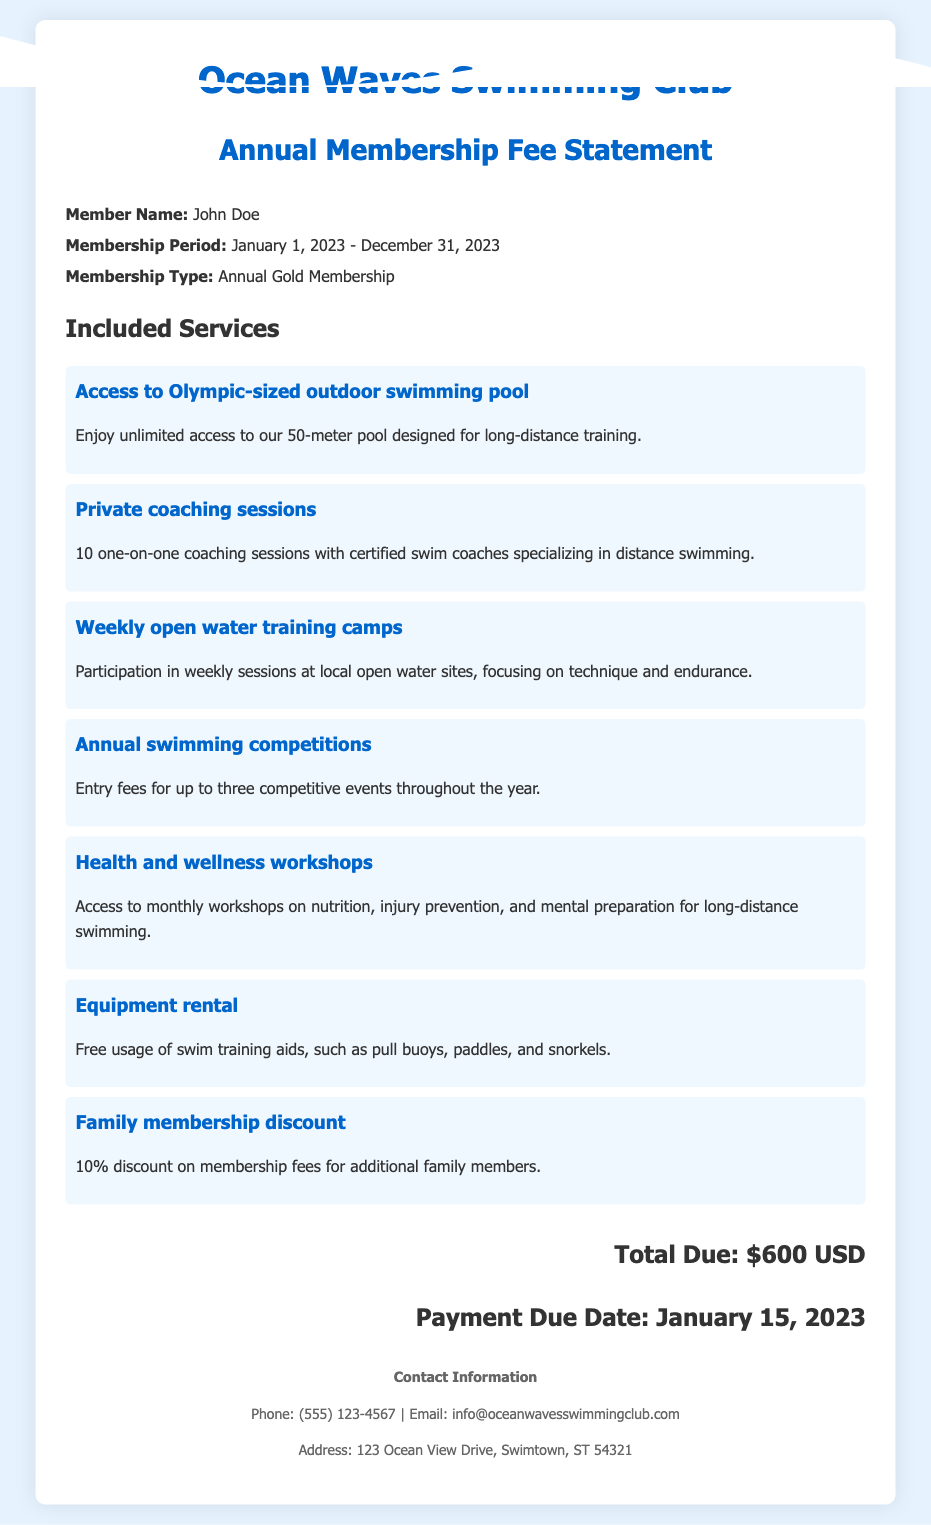What is the membership name? The membership name is indicated in the member info section of the document, which is "John Doe."
Answer: John Doe What is the membership period? The membership period is provided in the member info section, covering a specific timeframe from start to end.
Answer: January 1, 2023 - December 31, 2023 How many coaching sessions are included? The document specifies the number of coaching sessions provided as part of the membership, which is mentioned in the services section.
Answer: 10 What type of pool access is available? The type of pool access is detailed in the services section, describing the pool's specifications for training purposes.
Answer: Olympic-sized outdoor swimming pool What is the total due amount? The total due amount is listed at the bottom of the document clearly indicating the fee expected to be paid.
Answer: $600 USD When is the payment due date? The payment due date is provided in the total section, indicating when the payment must be made.
Answer: January 15, 2023 What discount is offered for family membership? The document mentions a specific discount for additional family members as part of the membership benefits.
Answer: 10% What workshops are included in the membership? The membership includes access to workshops as listed in the services section, focusing on various topics for swimmers.
Answer: Health and wellness workshops How many competitive events can members enter? The limit on competitive events available to members is stated in the services section.
Answer: Three 